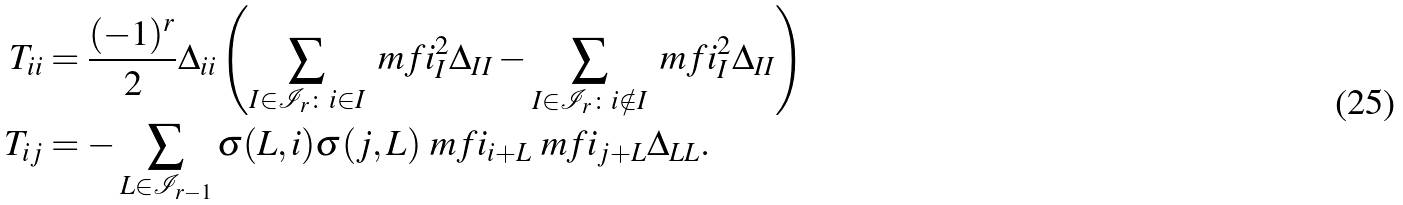Convert formula to latex. <formula><loc_0><loc_0><loc_500><loc_500>T _ { i i } & = \frac { ( - 1 ) ^ { r } } { 2 } \Delta _ { i i } \left ( \sum _ { I \in \mathcal { I } _ { r } \colon i \in I } \ m f i _ { I } ^ { 2 } \Delta _ { I I } - \sum _ { I \in \mathcal { I } _ { r } \colon i \notin I } \ m f i _ { I } ^ { 2 } \Delta _ { I I } \right ) \\ T _ { i j } & = - \sum _ { L \in \mathcal { I } _ { r - 1 } } \sigma ( L , i ) \sigma ( j , L ) \ m f i _ { i + L } \ m f i _ { j + L } \Delta _ { L L } .</formula> 